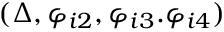<formula> <loc_0><loc_0><loc_500><loc_500>( \Delta , \varphi _ { i 2 } , \varphi _ { i 3 } . \varphi _ { i 4 } )</formula> 